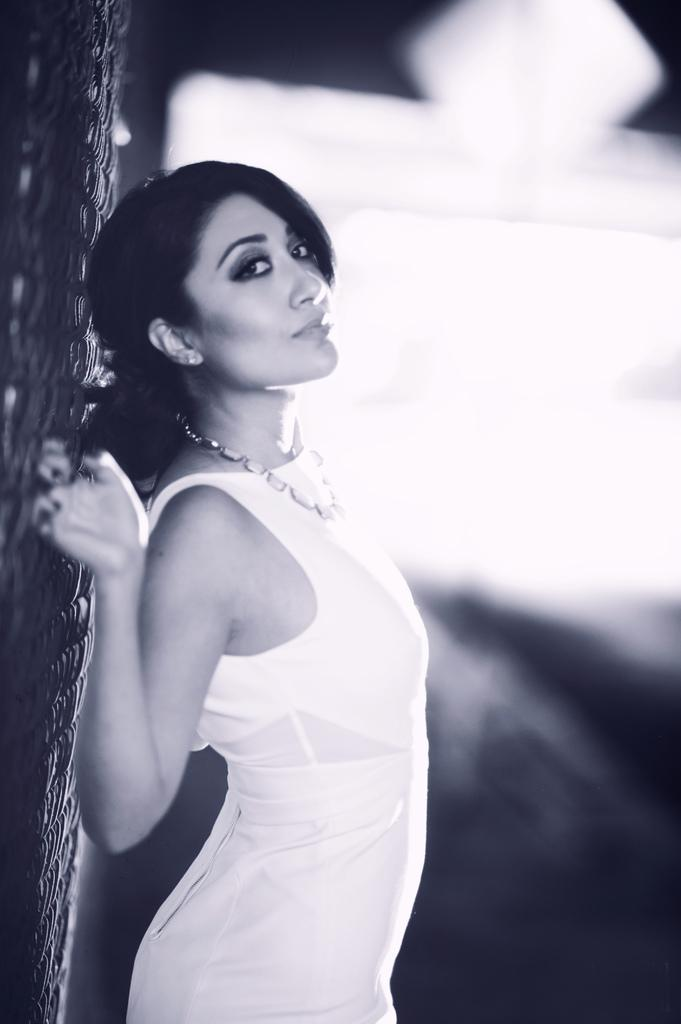What is the color scheme of the image? The image is black and white. Who is the main subject in the image? There is a girl in the image. Where is the girl positioned in the image? The girl is standing in the middle of the image. What is the girl holding in the image? The girl is holding a grill. Where is the grill located in relation to the girl? The grill is behind the girl. How would you describe the background of the image? The background of the image appears blurry. What type of box can be seen in the image? There is no box present in the image. What tax is being discussed in the image? There is no discussion of taxes in the image. 